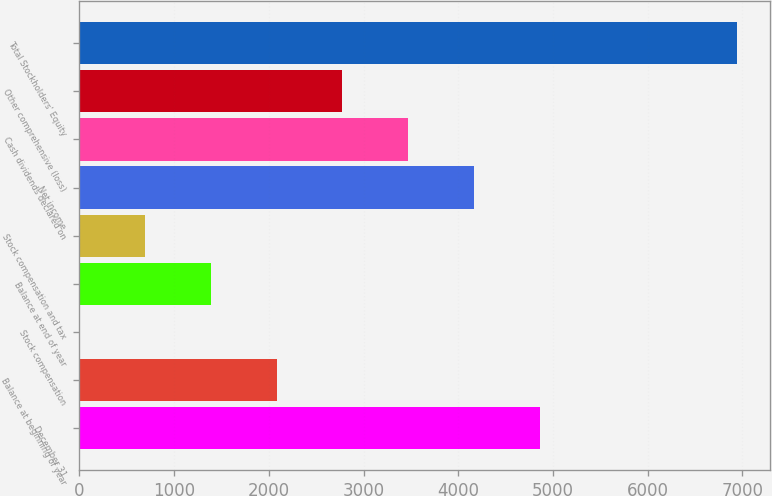Convert chart to OTSL. <chart><loc_0><loc_0><loc_500><loc_500><bar_chart><fcel>December 31<fcel>Balance at beginning of year<fcel>Stock compensation<fcel>Balance at end of year<fcel>Stock compensation and tax<fcel>Net income<fcel>Cash dividends declared on<fcel>Other comprehensive (loss)<fcel>Total Stockholders' Equity<nl><fcel>4858.49<fcel>2082.61<fcel>0.7<fcel>1388.64<fcel>694.67<fcel>4164.52<fcel>3470.55<fcel>2776.58<fcel>6940.4<nl></chart> 